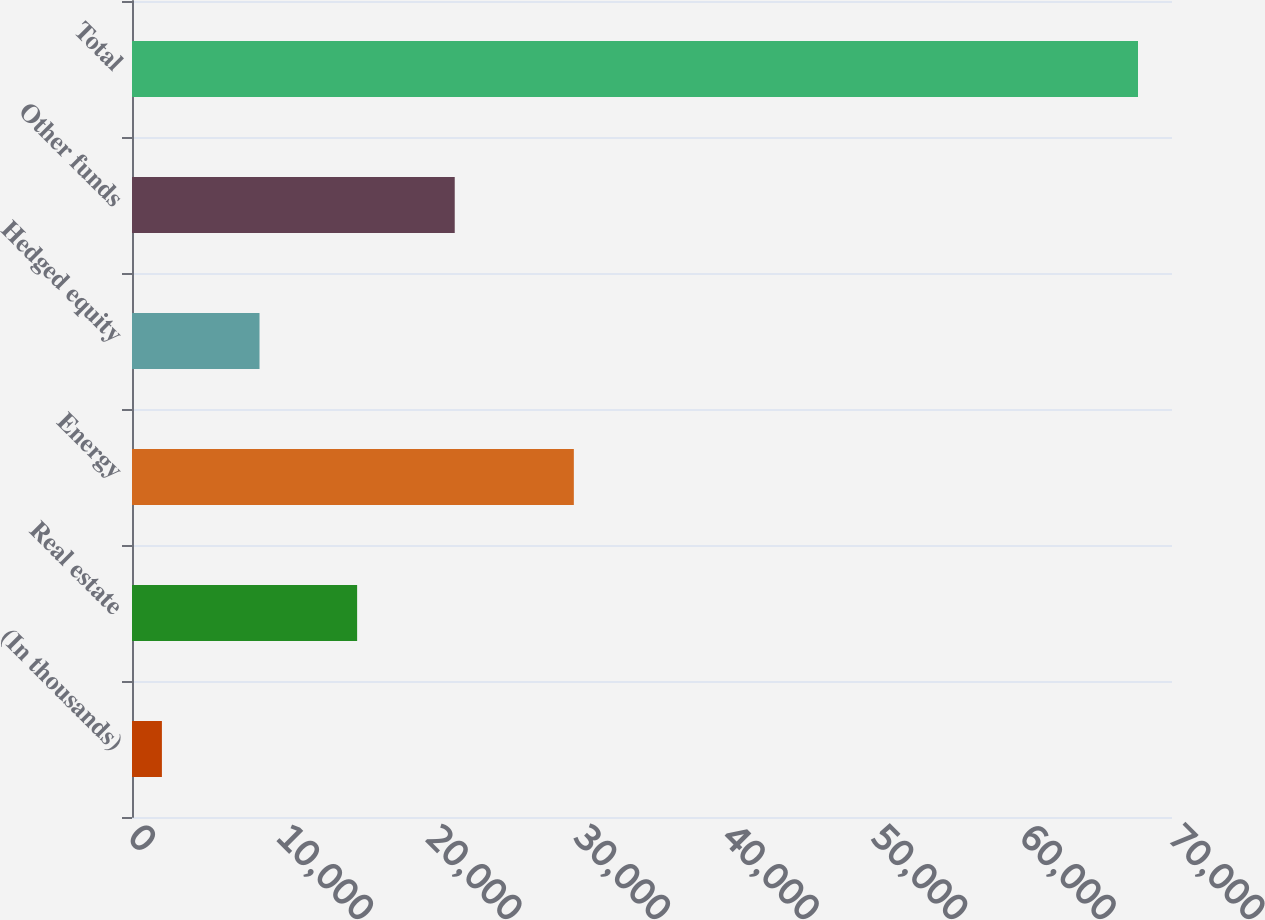Convert chart. <chart><loc_0><loc_0><loc_500><loc_500><bar_chart><fcel>(In thousands)<fcel>Real estate<fcel>Energy<fcel>Hedged equity<fcel>Other funds<fcel>Total<nl><fcel>2013<fcel>15152.8<fcel>29739<fcel>8582.9<fcel>21722.7<fcel>67712<nl></chart> 